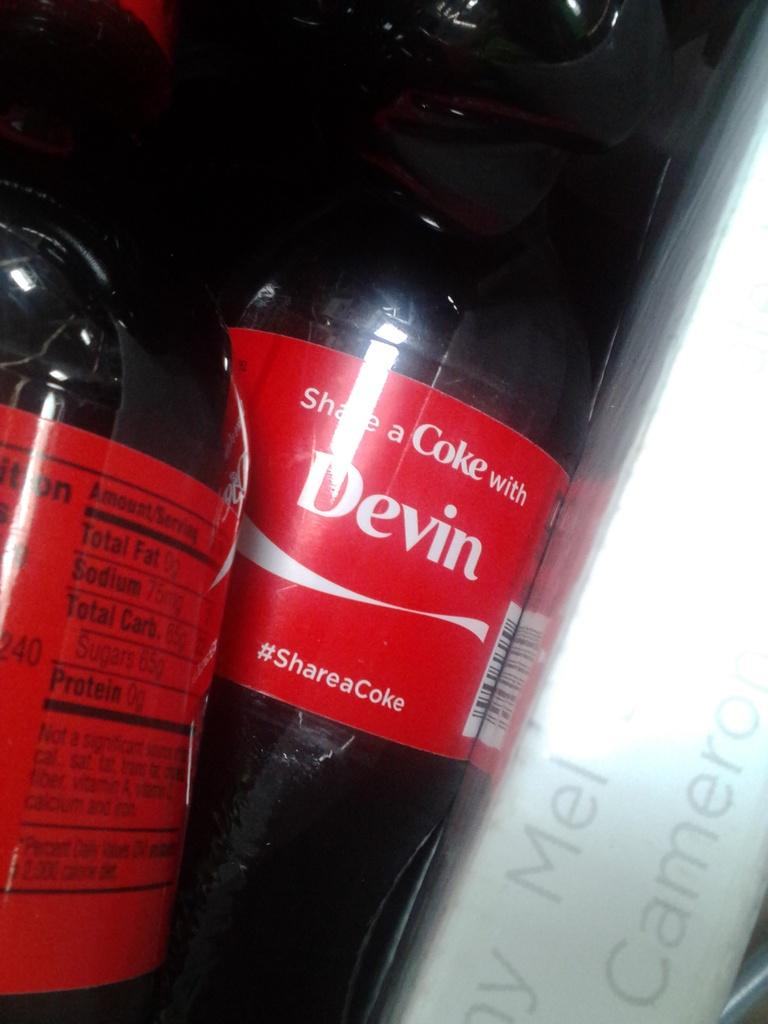Provide a one-sentence caption for the provided image. A bottle of Coke has the name Devin printed on the label. 